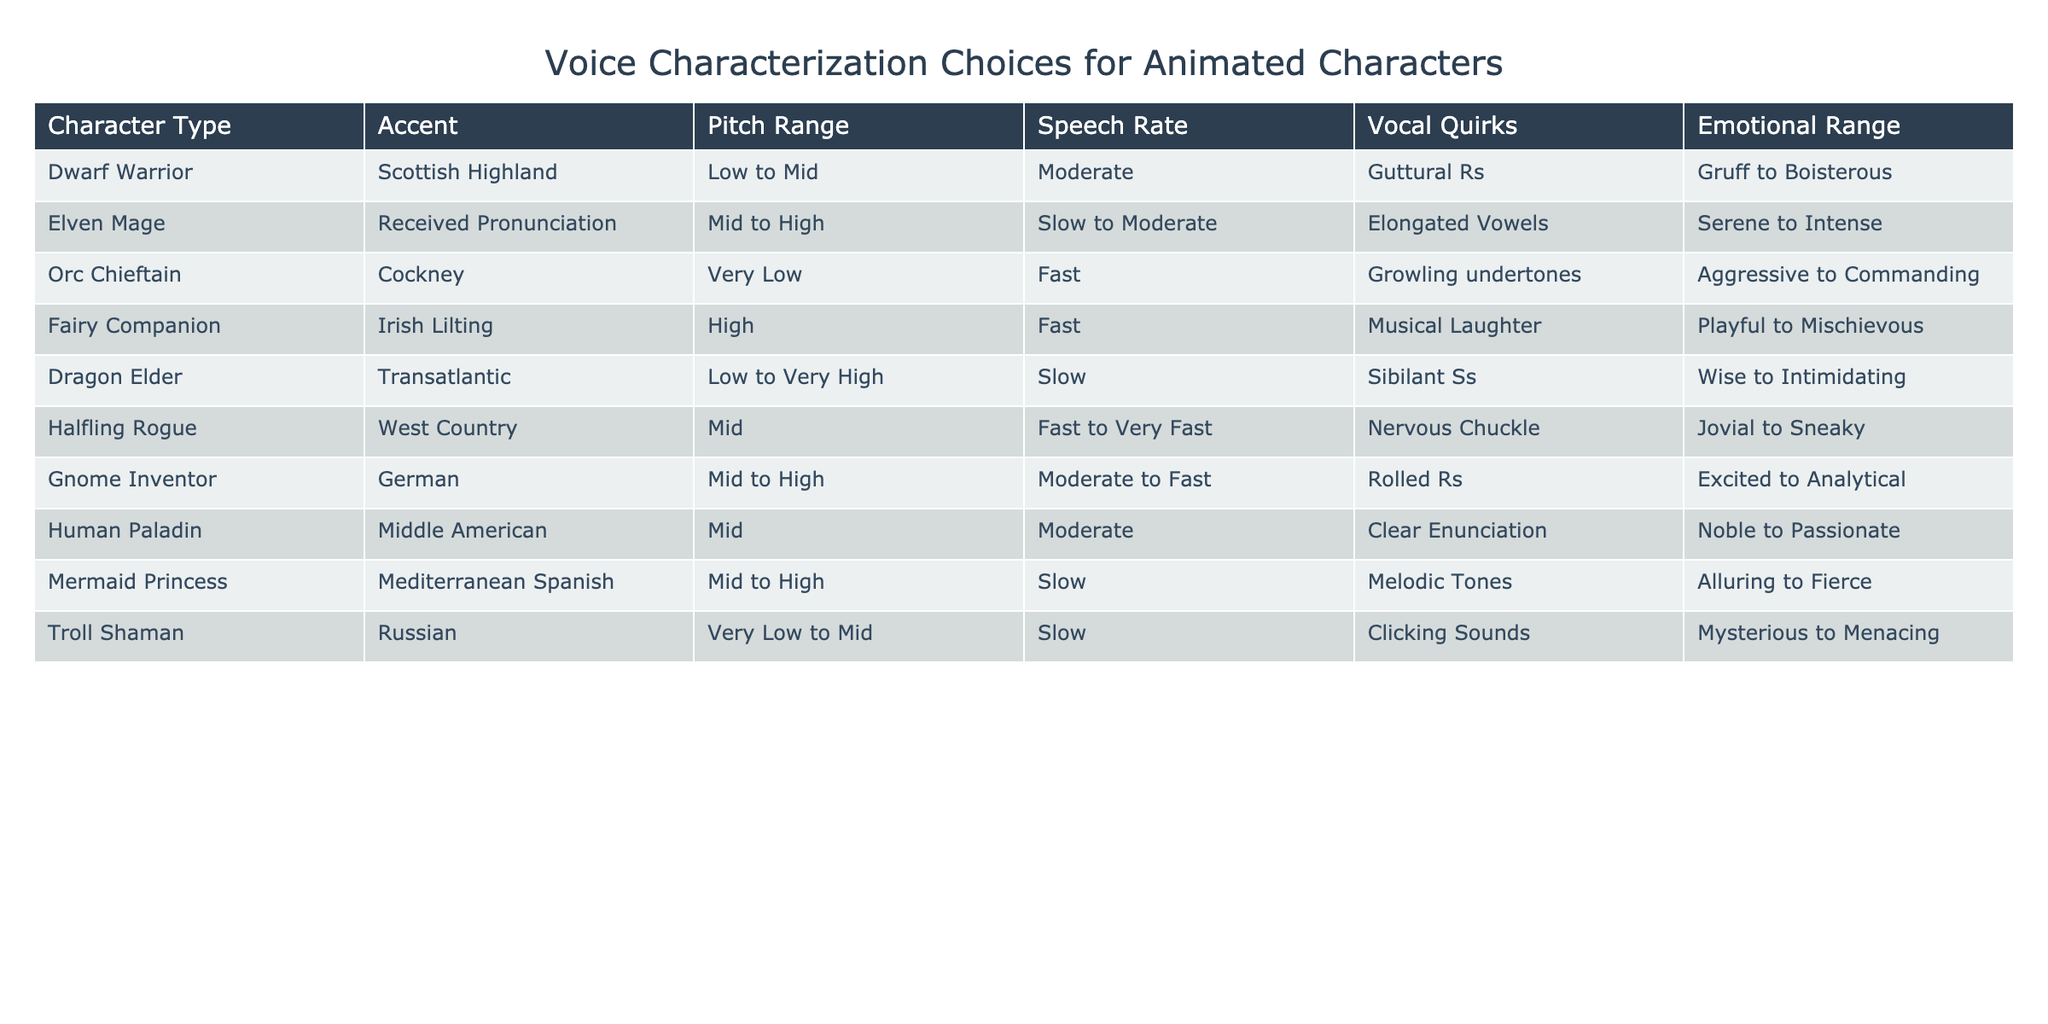What accent does the Halfling Rogue have? The table indicates that the Halfling Rogue has a West Country accent.
Answer: West Country Which character has a very low pitch range? The Orc Chieftain is noted to have a very low pitch range according to the table.
Answer: Orc Chieftain How many characters have a high emotional range? The Fairy Companion, Mermaid Princess, and Elven Mage are listed as having varying high emotional ranges, totaling three characters.
Answer: 3 Is the Dragon Elder's speech rate fast? The table states that the Dragon Elder has a slow speech rate, so the statement is false.
Answer: No What is the pitch range of the Dwarf Warrior? The Dwarf Warrior has a pitch range listed as low to mid.
Answer: Low to Mid Which character has musical laughter as a vocal quirk? According to the table, the Fairy Companion is characterized by musical laughter.
Answer: Fairy Companion Which character has the widest emotional range? Analyzing the characters, both the Dwarf Warrior (Gruff to Boisterous) and the Orc Chieftain (Aggressive to Commanding) suggest a broad range, but the Dwarf Warrior's emotional range includes a more playful and boisterous aspect, giving it a more varied emotional expression.
Answer: Dwarf Warrior What is the accent of the Mermaid Princess? The Mermaid Princess is stated to have a Mediterranean Spanish accent.
Answer: Mediterranean Spanish If we consider characters with moderate speech rates, how many are there? The characters with moderate speech rates include the Dwarf Warrior, Gnome Inventor, Human Paladin, and the Elven Mage, leading to a total of four characters fitting this criterion.
Answer: 4 